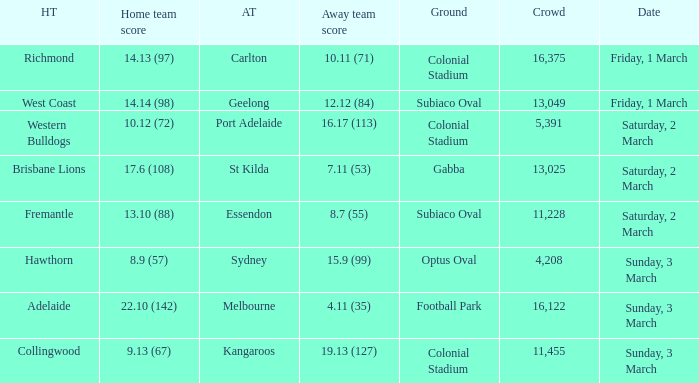Where did the away team essendon have their home base? Subiaco Oval. 